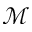<formula> <loc_0><loc_0><loc_500><loc_500>\mathcal { M }</formula> 